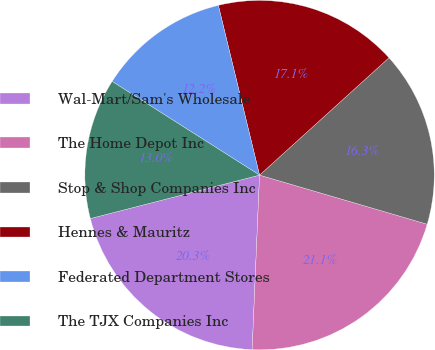Convert chart. <chart><loc_0><loc_0><loc_500><loc_500><pie_chart><fcel>Wal-Mart/Sam's Wholesale<fcel>The Home Depot Inc<fcel>Stop & Shop Companies Inc<fcel>Hennes & Mauritz<fcel>Federated Department Stores<fcel>The TJX Companies Inc<nl><fcel>20.33%<fcel>21.14%<fcel>16.26%<fcel>17.07%<fcel>12.2%<fcel>13.01%<nl></chart> 